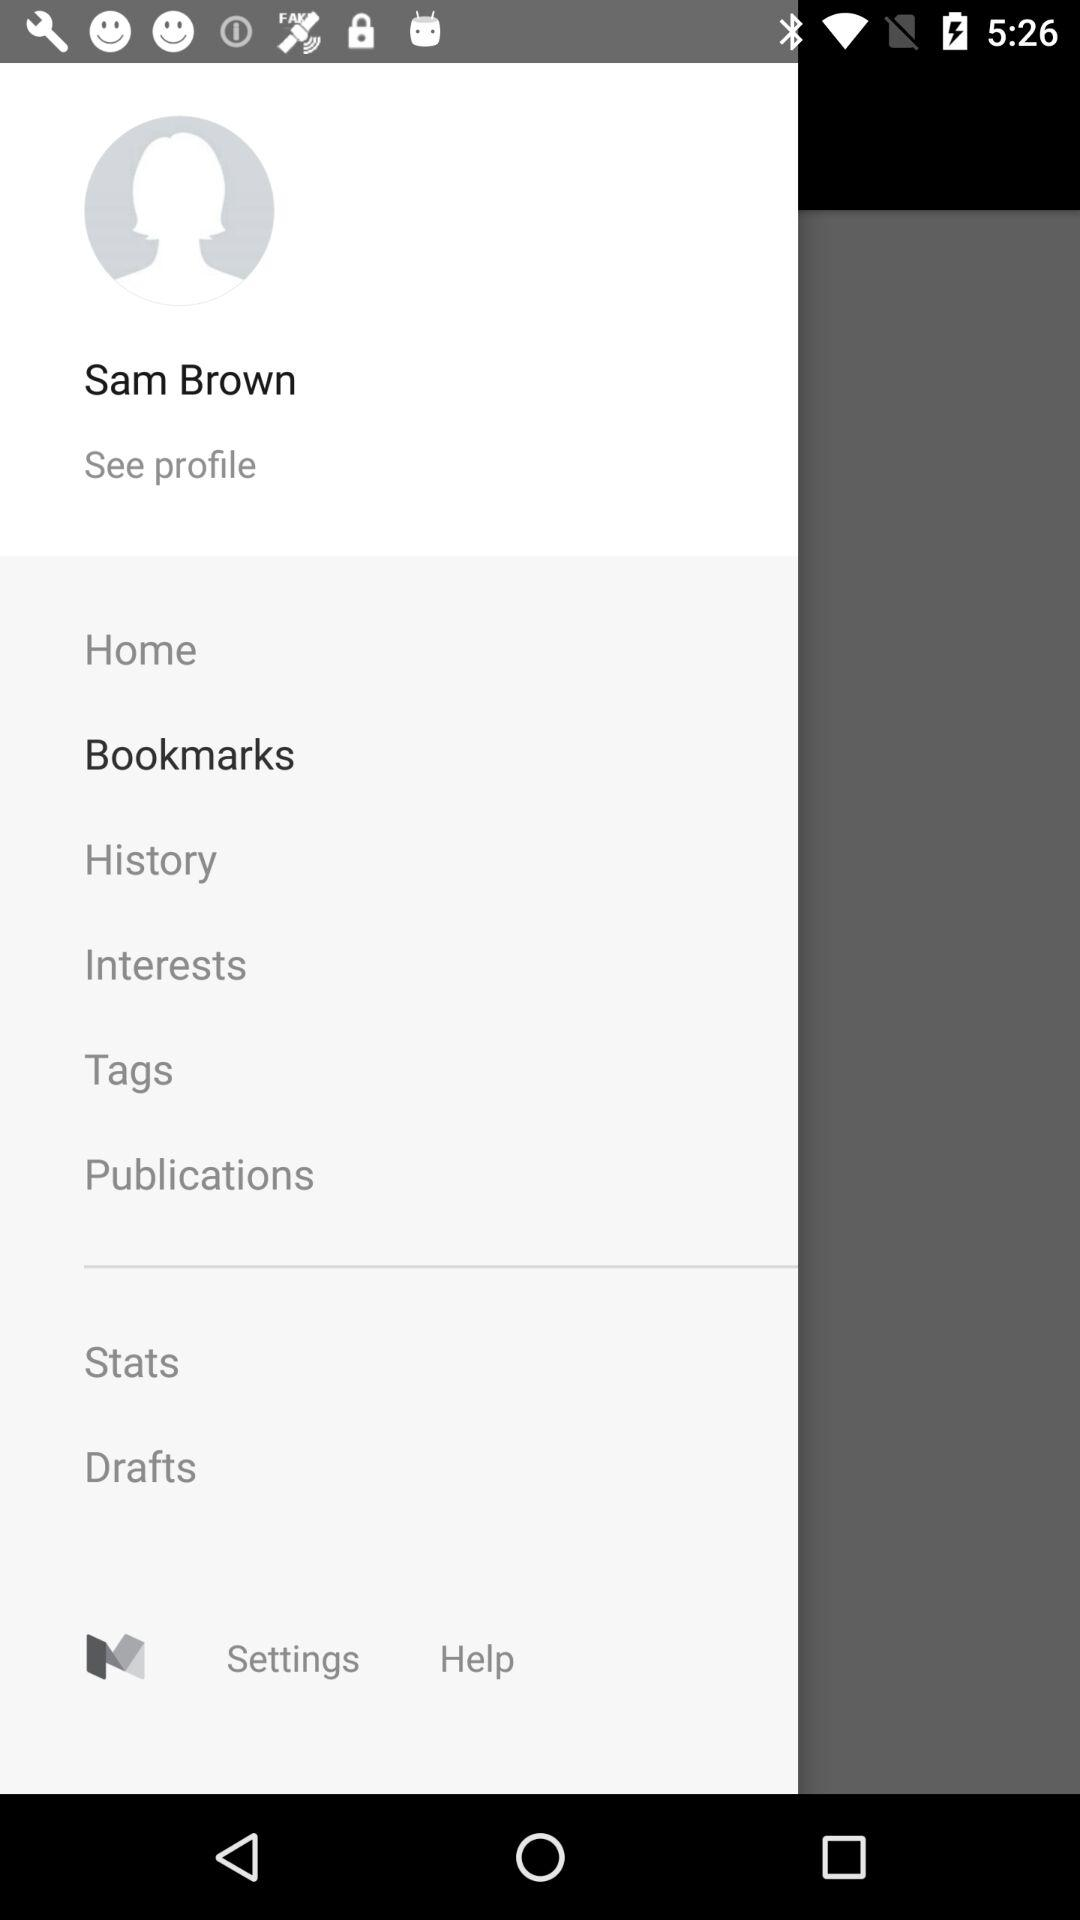What is the profile name? The profile name is Sam Brown. 